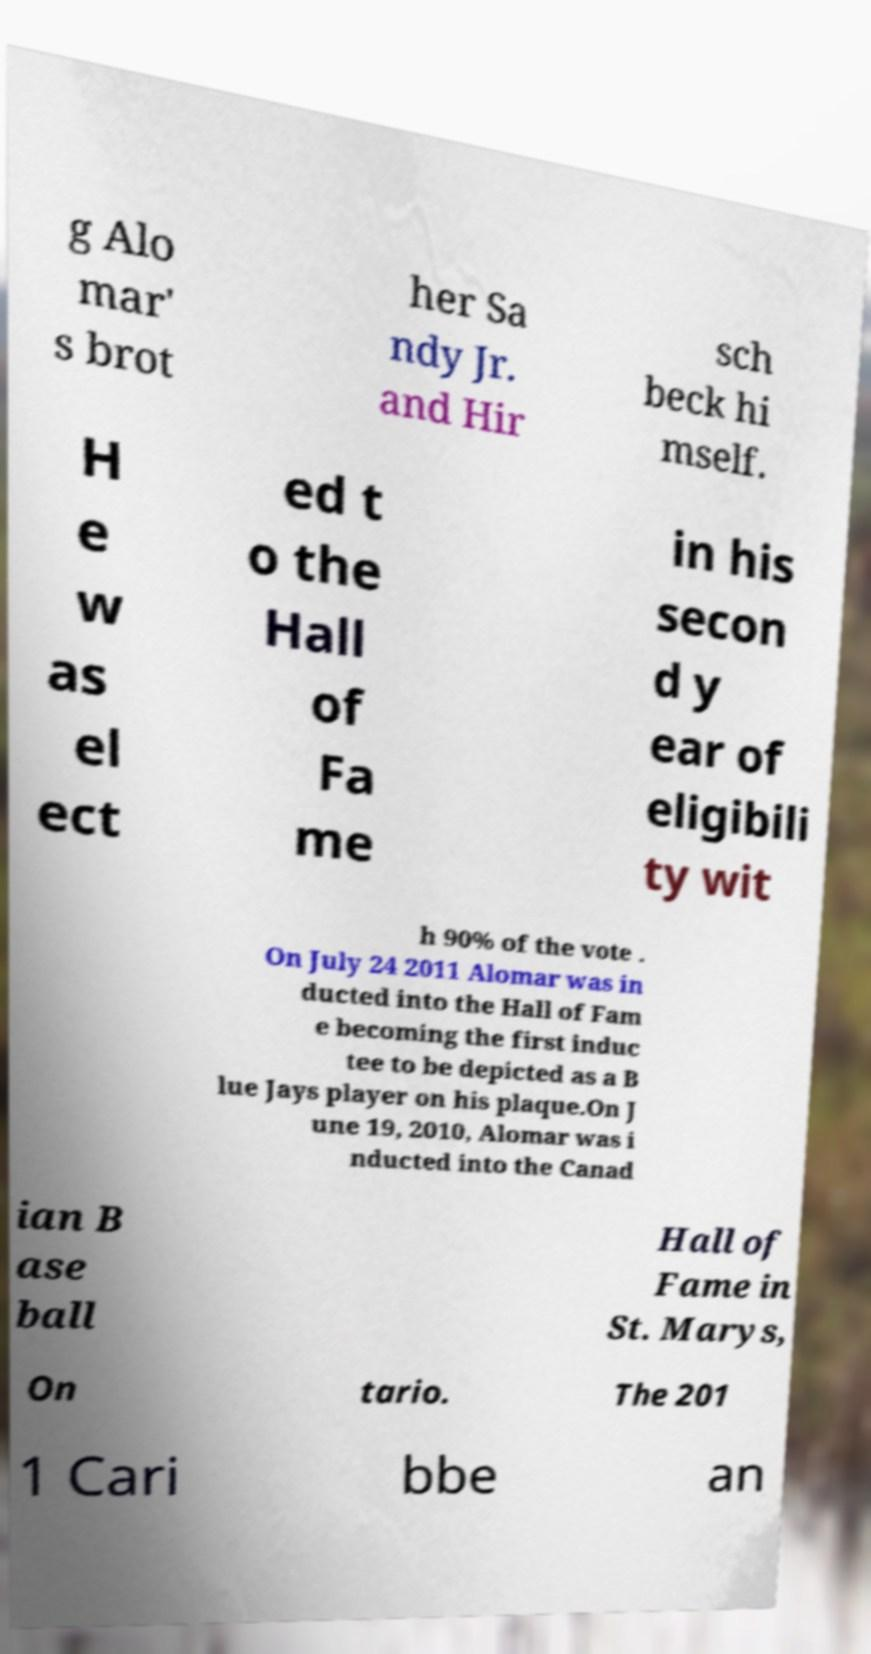Could you extract and type out the text from this image? g Alo mar' s brot her Sa ndy Jr. and Hir sch beck hi mself. H e w as el ect ed t o the Hall of Fa me in his secon d y ear of eligibili ty wit h 90% of the vote . On July 24 2011 Alomar was in ducted into the Hall of Fam e becoming the first induc tee to be depicted as a B lue Jays player on his plaque.On J une 19, 2010, Alomar was i nducted into the Canad ian B ase ball Hall of Fame in St. Marys, On tario. The 201 1 Cari bbe an 